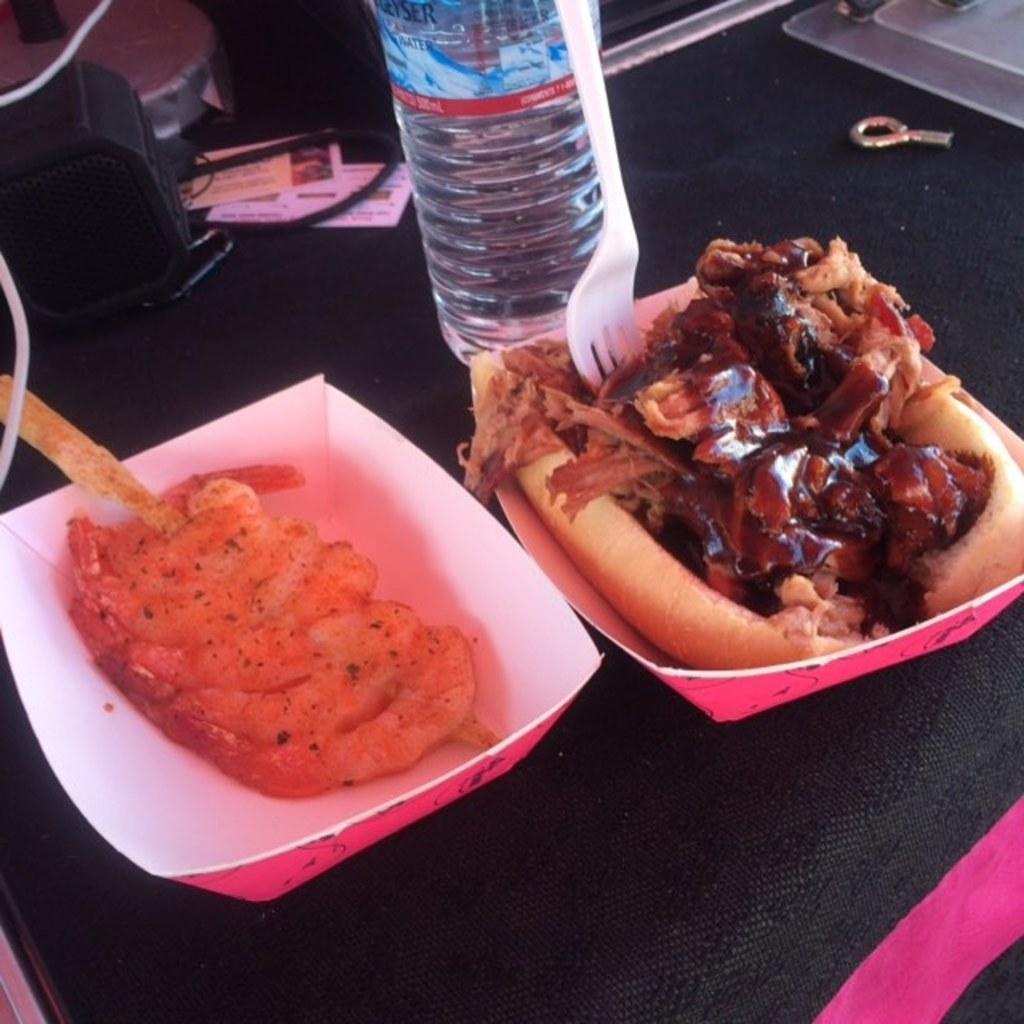Describe this image in one or two sentences. In this picture we can see food in the paper plates, beside to the plates we can find a bottle and other things, and also we can see a fork. 